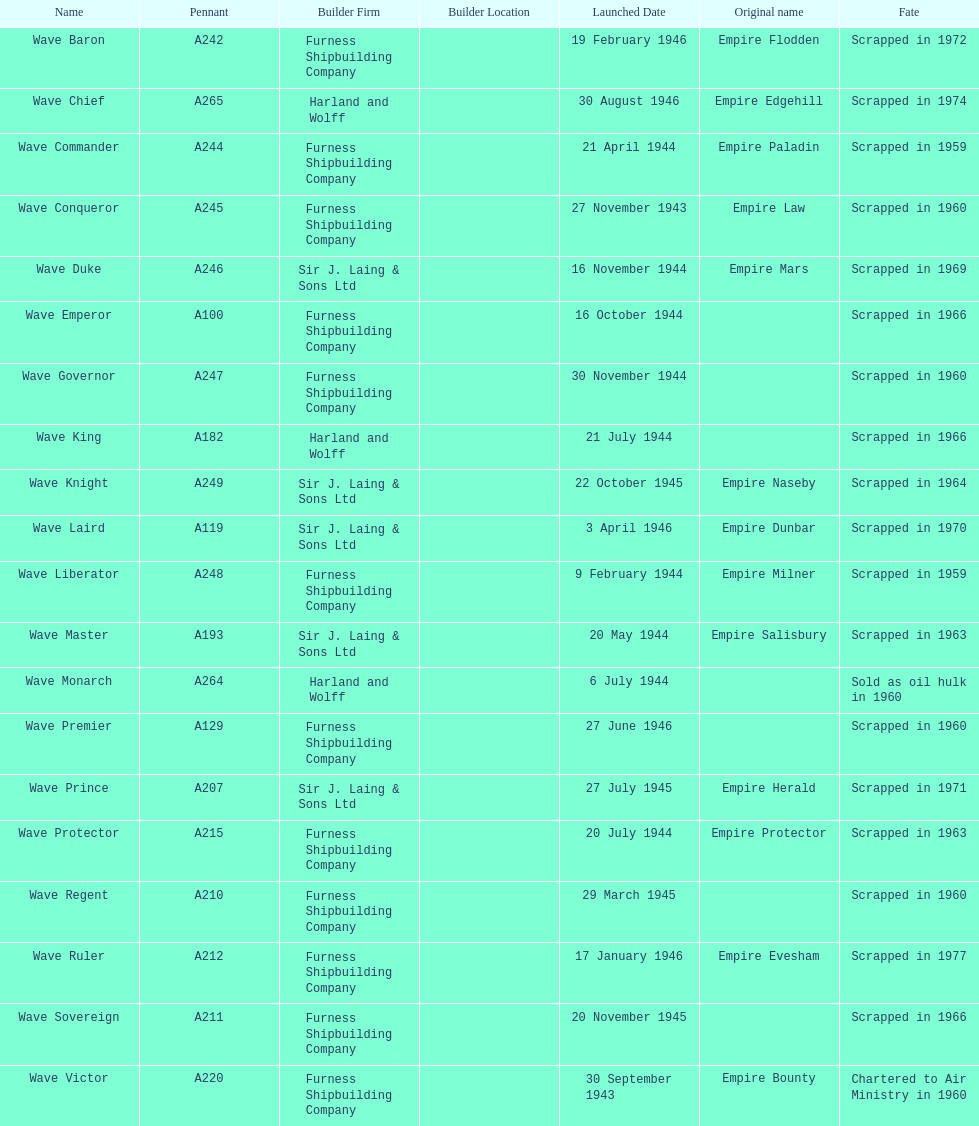Which other ship was launched in the same year as the wave victor? Wave Conqueror. 